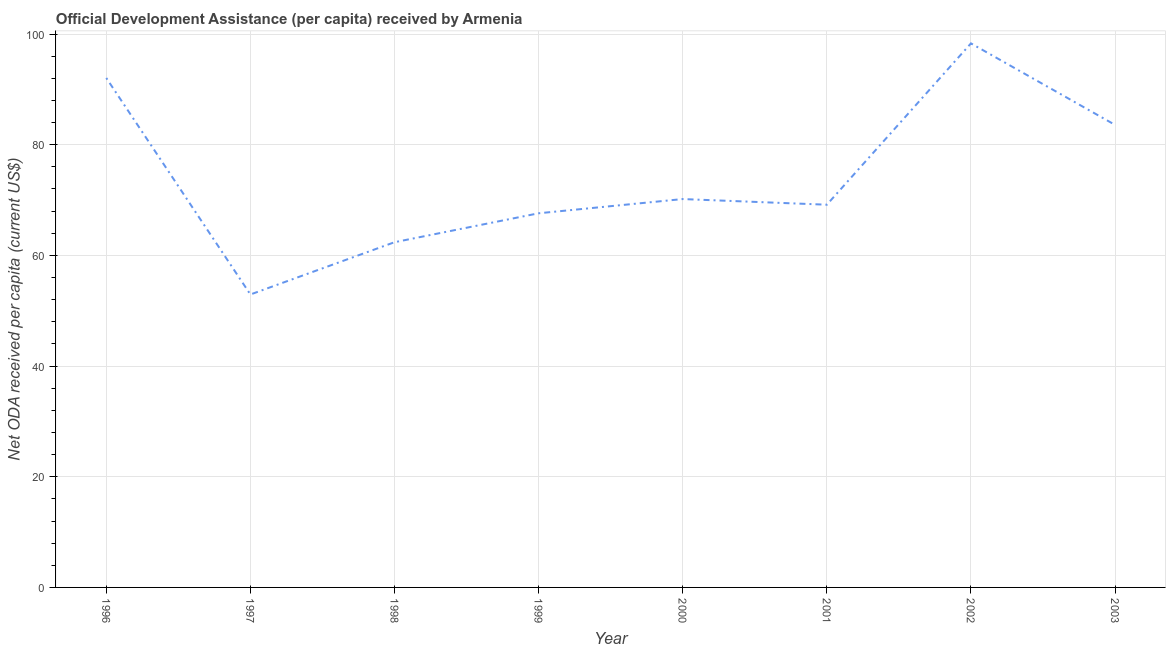What is the net oda received per capita in 1996?
Give a very brief answer. 92.06. Across all years, what is the maximum net oda received per capita?
Give a very brief answer. 98.31. Across all years, what is the minimum net oda received per capita?
Give a very brief answer. 52.94. In which year was the net oda received per capita maximum?
Your answer should be very brief. 2002. What is the sum of the net oda received per capita?
Your answer should be compact. 596.24. What is the difference between the net oda received per capita in 1999 and 2001?
Give a very brief answer. -1.55. What is the average net oda received per capita per year?
Your answer should be compact. 74.53. What is the median net oda received per capita?
Keep it short and to the point. 69.67. Do a majority of the years between 2001 and 2000 (inclusive) have net oda received per capita greater than 12 US$?
Keep it short and to the point. No. What is the ratio of the net oda received per capita in 2001 to that in 2003?
Offer a terse response. 0.83. Is the difference between the net oda received per capita in 2000 and 2003 greater than the difference between any two years?
Make the answer very short. No. What is the difference between the highest and the second highest net oda received per capita?
Provide a succinct answer. 6.25. Is the sum of the net oda received per capita in 2000 and 2001 greater than the maximum net oda received per capita across all years?
Provide a succinct answer. Yes. What is the difference between the highest and the lowest net oda received per capita?
Offer a terse response. 45.38. Does the net oda received per capita monotonically increase over the years?
Your answer should be compact. No. How many lines are there?
Give a very brief answer. 1. How many years are there in the graph?
Offer a terse response. 8. What is the difference between two consecutive major ticks on the Y-axis?
Keep it short and to the point. 20. Does the graph contain any zero values?
Your answer should be very brief. No. Does the graph contain grids?
Your response must be concise. Yes. What is the title of the graph?
Your answer should be very brief. Official Development Assistance (per capita) received by Armenia. What is the label or title of the Y-axis?
Ensure brevity in your answer.  Net ODA received per capita (current US$). What is the Net ODA received per capita (current US$) of 1996?
Offer a terse response. 92.06. What is the Net ODA received per capita (current US$) in 1997?
Give a very brief answer. 52.94. What is the Net ODA received per capita (current US$) of 1998?
Keep it short and to the point. 62.38. What is the Net ODA received per capita (current US$) in 1999?
Give a very brief answer. 67.61. What is the Net ODA received per capita (current US$) in 2000?
Your response must be concise. 70.18. What is the Net ODA received per capita (current US$) of 2001?
Your answer should be compact. 69.16. What is the Net ODA received per capita (current US$) of 2002?
Your answer should be compact. 98.31. What is the Net ODA received per capita (current US$) in 2003?
Provide a short and direct response. 83.59. What is the difference between the Net ODA received per capita (current US$) in 1996 and 1997?
Provide a succinct answer. 39.13. What is the difference between the Net ODA received per capita (current US$) in 1996 and 1998?
Offer a very short reply. 29.68. What is the difference between the Net ODA received per capita (current US$) in 1996 and 1999?
Offer a terse response. 24.45. What is the difference between the Net ODA received per capita (current US$) in 1996 and 2000?
Give a very brief answer. 21.88. What is the difference between the Net ODA received per capita (current US$) in 1996 and 2001?
Provide a succinct answer. 22.91. What is the difference between the Net ODA received per capita (current US$) in 1996 and 2002?
Offer a terse response. -6.25. What is the difference between the Net ODA received per capita (current US$) in 1996 and 2003?
Your answer should be very brief. 8.48. What is the difference between the Net ODA received per capita (current US$) in 1997 and 1998?
Keep it short and to the point. -9.45. What is the difference between the Net ODA received per capita (current US$) in 1997 and 1999?
Give a very brief answer. -14.67. What is the difference between the Net ODA received per capita (current US$) in 1997 and 2000?
Your answer should be very brief. -17.25. What is the difference between the Net ODA received per capita (current US$) in 1997 and 2001?
Your response must be concise. -16.22. What is the difference between the Net ODA received per capita (current US$) in 1997 and 2002?
Your answer should be very brief. -45.38. What is the difference between the Net ODA received per capita (current US$) in 1997 and 2003?
Provide a short and direct response. -30.65. What is the difference between the Net ODA received per capita (current US$) in 1998 and 1999?
Provide a short and direct response. -5.23. What is the difference between the Net ODA received per capita (current US$) in 1998 and 2000?
Make the answer very short. -7.8. What is the difference between the Net ODA received per capita (current US$) in 1998 and 2001?
Your answer should be very brief. -6.77. What is the difference between the Net ODA received per capita (current US$) in 1998 and 2002?
Offer a very short reply. -35.93. What is the difference between the Net ODA received per capita (current US$) in 1998 and 2003?
Offer a terse response. -21.2. What is the difference between the Net ODA received per capita (current US$) in 1999 and 2000?
Give a very brief answer. -2.57. What is the difference between the Net ODA received per capita (current US$) in 1999 and 2001?
Your response must be concise. -1.55. What is the difference between the Net ODA received per capita (current US$) in 1999 and 2002?
Give a very brief answer. -30.7. What is the difference between the Net ODA received per capita (current US$) in 1999 and 2003?
Your answer should be compact. -15.97. What is the difference between the Net ODA received per capita (current US$) in 2000 and 2001?
Your answer should be very brief. 1.02. What is the difference between the Net ODA received per capita (current US$) in 2000 and 2002?
Make the answer very short. -28.13. What is the difference between the Net ODA received per capita (current US$) in 2000 and 2003?
Your answer should be very brief. -13.4. What is the difference between the Net ODA received per capita (current US$) in 2001 and 2002?
Offer a terse response. -29.16. What is the difference between the Net ODA received per capita (current US$) in 2001 and 2003?
Ensure brevity in your answer.  -14.43. What is the difference between the Net ODA received per capita (current US$) in 2002 and 2003?
Keep it short and to the point. 14.73. What is the ratio of the Net ODA received per capita (current US$) in 1996 to that in 1997?
Offer a very short reply. 1.74. What is the ratio of the Net ODA received per capita (current US$) in 1996 to that in 1998?
Offer a terse response. 1.48. What is the ratio of the Net ODA received per capita (current US$) in 1996 to that in 1999?
Your answer should be very brief. 1.36. What is the ratio of the Net ODA received per capita (current US$) in 1996 to that in 2000?
Keep it short and to the point. 1.31. What is the ratio of the Net ODA received per capita (current US$) in 1996 to that in 2001?
Provide a short and direct response. 1.33. What is the ratio of the Net ODA received per capita (current US$) in 1996 to that in 2002?
Ensure brevity in your answer.  0.94. What is the ratio of the Net ODA received per capita (current US$) in 1996 to that in 2003?
Offer a terse response. 1.1. What is the ratio of the Net ODA received per capita (current US$) in 1997 to that in 1998?
Keep it short and to the point. 0.85. What is the ratio of the Net ODA received per capita (current US$) in 1997 to that in 1999?
Provide a succinct answer. 0.78. What is the ratio of the Net ODA received per capita (current US$) in 1997 to that in 2000?
Your answer should be compact. 0.75. What is the ratio of the Net ODA received per capita (current US$) in 1997 to that in 2001?
Your response must be concise. 0.77. What is the ratio of the Net ODA received per capita (current US$) in 1997 to that in 2002?
Give a very brief answer. 0.54. What is the ratio of the Net ODA received per capita (current US$) in 1997 to that in 2003?
Your response must be concise. 0.63. What is the ratio of the Net ODA received per capita (current US$) in 1998 to that in 1999?
Keep it short and to the point. 0.92. What is the ratio of the Net ODA received per capita (current US$) in 1998 to that in 2000?
Keep it short and to the point. 0.89. What is the ratio of the Net ODA received per capita (current US$) in 1998 to that in 2001?
Offer a terse response. 0.9. What is the ratio of the Net ODA received per capita (current US$) in 1998 to that in 2002?
Ensure brevity in your answer.  0.64. What is the ratio of the Net ODA received per capita (current US$) in 1998 to that in 2003?
Your response must be concise. 0.75. What is the ratio of the Net ODA received per capita (current US$) in 1999 to that in 2002?
Provide a short and direct response. 0.69. What is the ratio of the Net ODA received per capita (current US$) in 1999 to that in 2003?
Provide a short and direct response. 0.81. What is the ratio of the Net ODA received per capita (current US$) in 2000 to that in 2001?
Provide a succinct answer. 1.01. What is the ratio of the Net ODA received per capita (current US$) in 2000 to that in 2002?
Offer a very short reply. 0.71. What is the ratio of the Net ODA received per capita (current US$) in 2000 to that in 2003?
Make the answer very short. 0.84. What is the ratio of the Net ODA received per capita (current US$) in 2001 to that in 2002?
Provide a short and direct response. 0.7. What is the ratio of the Net ODA received per capita (current US$) in 2001 to that in 2003?
Your response must be concise. 0.83. What is the ratio of the Net ODA received per capita (current US$) in 2002 to that in 2003?
Give a very brief answer. 1.18. 